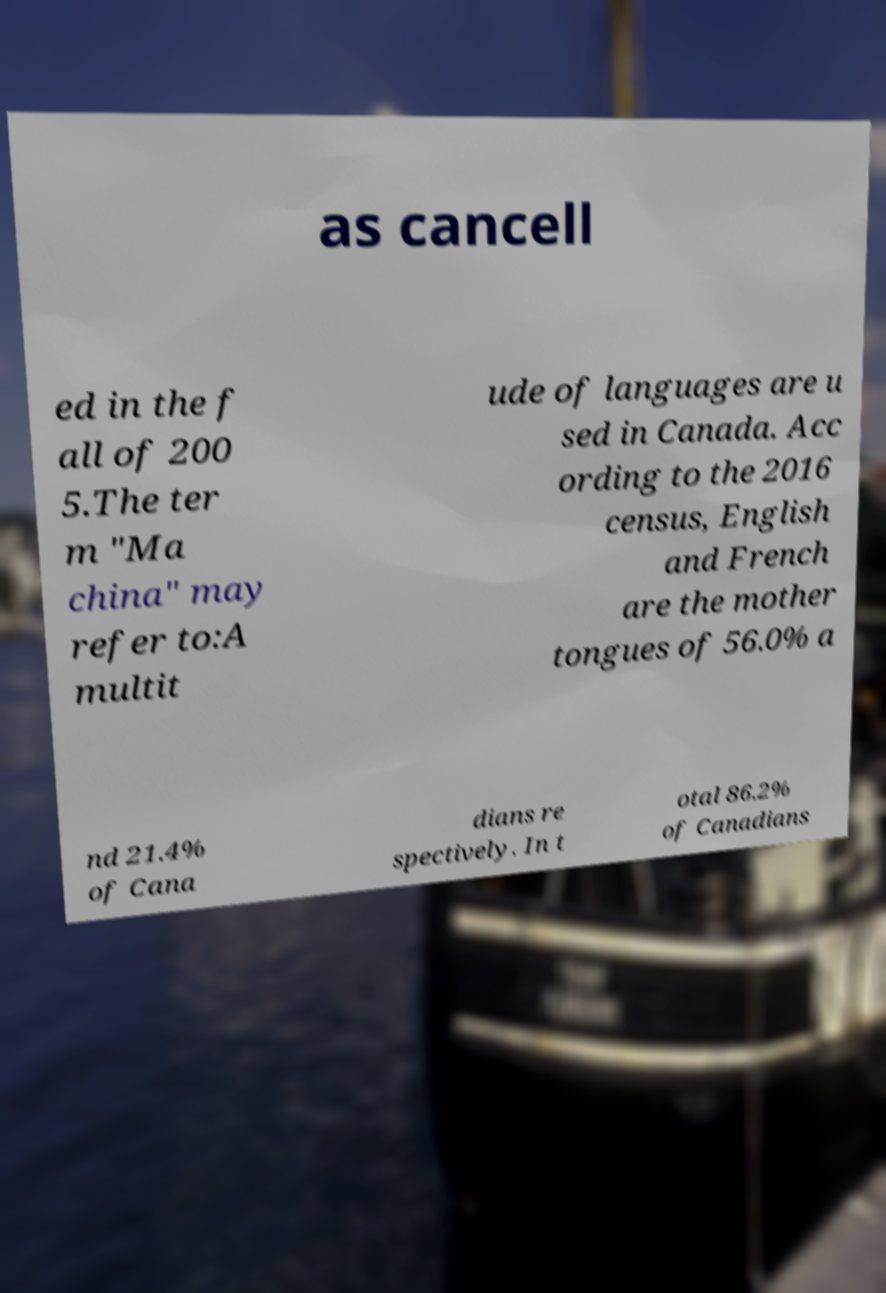There's text embedded in this image that I need extracted. Can you transcribe it verbatim? as cancell ed in the f all of 200 5.The ter m "Ma china" may refer to:A multit ude of languages are u sed in Canada. Acc ording to the 2016 census, English and French are the mother tongues of 56.0% a nd 21.4% of Cana dians re spectively. In t otal 86.2% of Canadians 